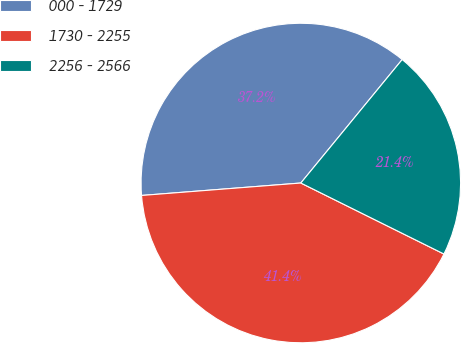<chart> <loc_0><loc_0><loc_500><loc_500><pie_chart><fcel>000 - 1729<fcel>1730 - 2255<fcel>2256 - 2566<nl><fcel>37.18%<fcel>41.43%<fcel>21.39%<nl></chart> 